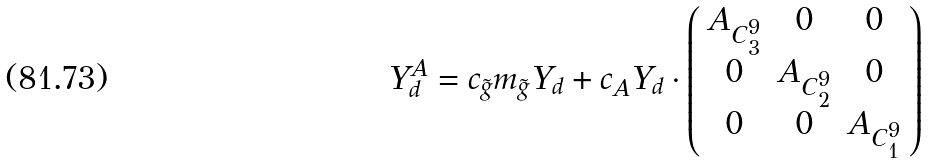Convert formula to latex. <formula><loc_0><loc_0><loc_500><loc_500>Y ^ { A } _ { d } = c _ { \tilde { g } } m _ { \tilde { g } } Y _ { d } + c _ { A } Y _ { d } \cdot \left ( \begin{array} { c c c } A _ { C ^ { 9 } _ { 3 } } & 0 & 0 \\ 0 & A _ { C ^ { 9 } _ { 2 } } & 0 \\ 0 & 0 & A _ { C ^ { 9 } _ { 1 } } \end{array} \right )</formula> 